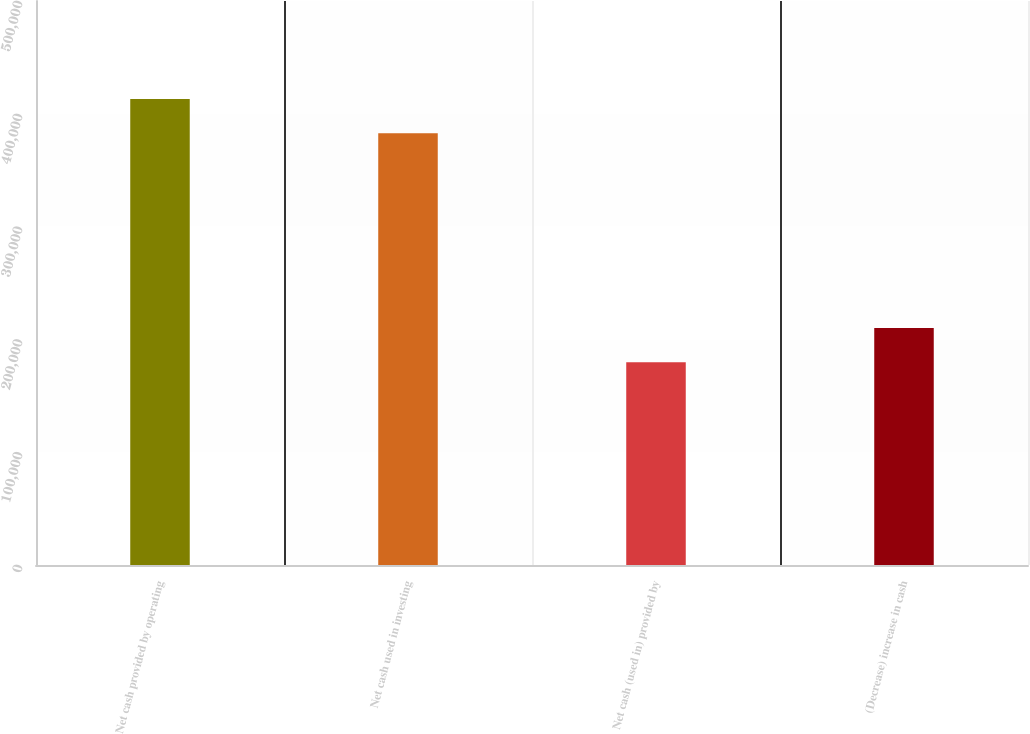Convert chart to OTSL. <chart><loc_0><loc_0><loc_500><loc_500><bar_chart><fcel>Net cash provided by operating<fcel>Net cash used in investing<fcel>Net cash (used in) provided by<fcel>(Decrease) increase in cash<nl><fcel>413140<fcel>382837<fcel>179744<fcel>210047<nl></chart> 